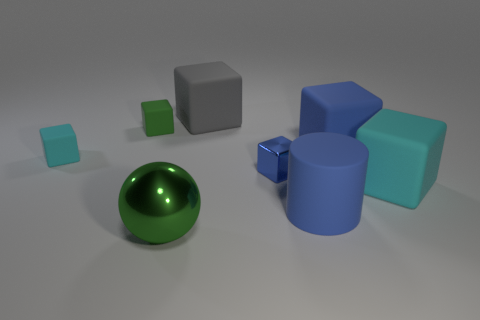The cyan rubber thing that is the same size as the gray thing is what shape?
Give a very brief answer. Cube. Is there any other thing that has the same color as the rubber cylinder?
Keep it short and to the point. Yes. The block that is the same material as the large green object is what size?
Ensure brevity in your answer.  Small. There is a tiny green thing; is its shape the same as the tiny object on the right side of the green shiny sphere?
Make the answer very short. Yes. What is the size of the gray thing?
Offer a terse response. Large. Are there fewer small green matte blocks that are in front of the small green rubber object than tiny rubber cubes?
Your answer should be compact. Yes. What number of blue blocks have the same size as the metallic sphere?
Provide a short and direct response. 1. What is the shape of the rubber thing that is the same color as the large rubber cylinder?
Give a very brief answer. Cube. There is a small object behind the small cyan rubber object; is it the same color as the big cube to the left of the big blue matte cylinder?
Make the answer very short. No. What number of tiny metallic things are in front of the big matte cylinder?
Your response must be concise. 0. 